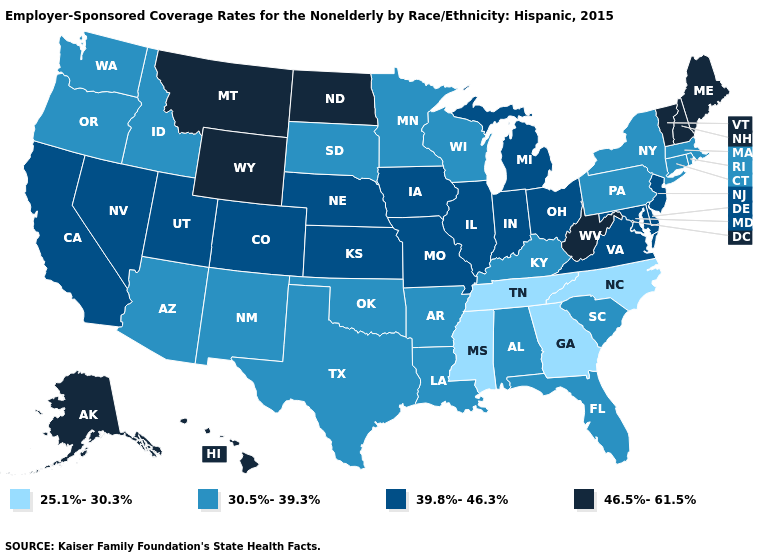Name the states that have a value in the range 39.8%-46.3%?
Give a very brief answer. California, Colorado, Delaware, Illinois, Indiana, Iowa, Kansas, Maryland, Michigan, Missouri, Nebraska, Nevada, New Jersey, Ohio, Utah, Virginia. Does Missouri have a lower value than Louisiana?
Quick response, please. No. Name the states that have a value in the range 46.5%-61.5%?
Answer briefly. Alaska, Hawaii, Maine, Montana, New Hampshire, North Dakota, Vermont, West Virginia, Wyoming. What is the lowest value in states that border Missouri?
Be succinct. 25.1%-30.3%. What is the highest value in states that border Florida?
Short answer required. 30.5%-39.3%. What is the lowest value in the West?
Give a very brief answer. 30.5%-39.3%. Does Utah have the highest value in the West?
Write a very short answer. No. What is the value of Iowa?
Answer briefly. 39.8%-46.3%. Name the states that have a value in the range 46.5%-61.5%?
Short answer required. Alaska, Hawaii, Maine, Montana, New Hampshire, North Dakota, Vermont, West Virginia, Wyoming. What is the highest value in states that border Nebraska?
Concise answer only. 46.5%-61.5%. Does the first symbol in the legend represent the smallest category?
Be succinct. Yes. What is the highest value in the USA?
Concise answer only. 46.5%-61.5%. What is the value of New Hampshire?
Short answer required. 46.5%-61.5%. Does Nevada have the lowest value in the West?
Keep it brief. No. What is the value of Arizona?
Short answer required. 30.5%-39.3%. 